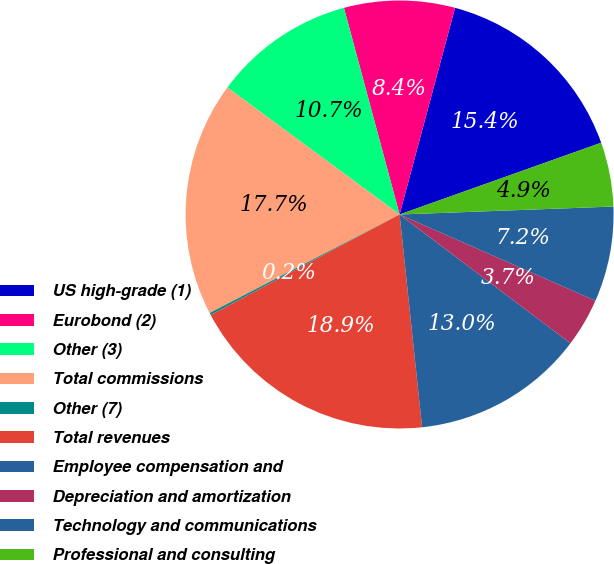Convert chart. <chart><loc_0><loc_0><loc_500><loc_500><pie_chart><fcel>US high-grade (1)<fcel>Eurobond (2)<fcel>Other (3)<fcel>Total commissions<fcel>Other (7)<fcel>Total revenues<fcel>Employee compensation and<fcel>Depreciation and amortization<fcel>Technology and communications<fcel>Professional and consulting<nl><fcel>15.38%<fcel>8.36%<fcel>10.7%<fcel>17.72%<fcel>0.17%<fcel>18.89%<fcel>13.04%<fcel>3.68%<fcel>7.19%<fcel>4.85%<nl></chart> 